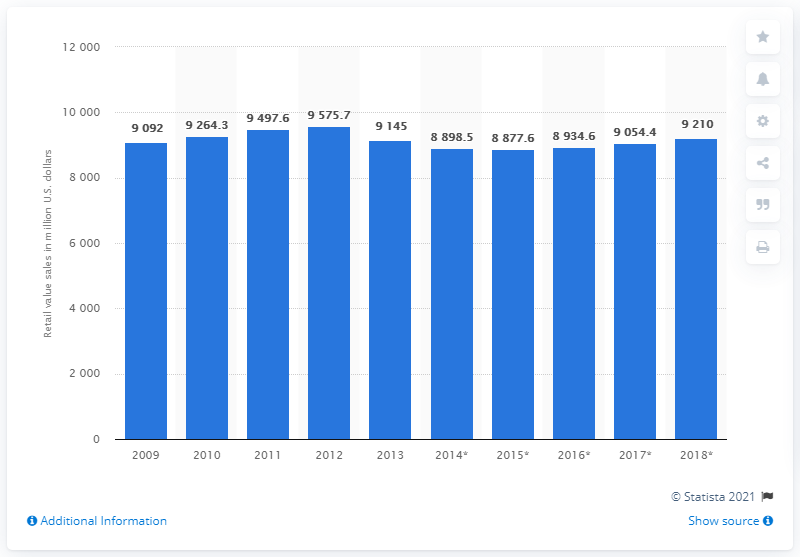Identify some key points in this picture. The retail sales value of cheese is expected to increase in 2018 to 9210. The retail sales value of cheese in Italy in 2013 was 9054.4 million euros. 